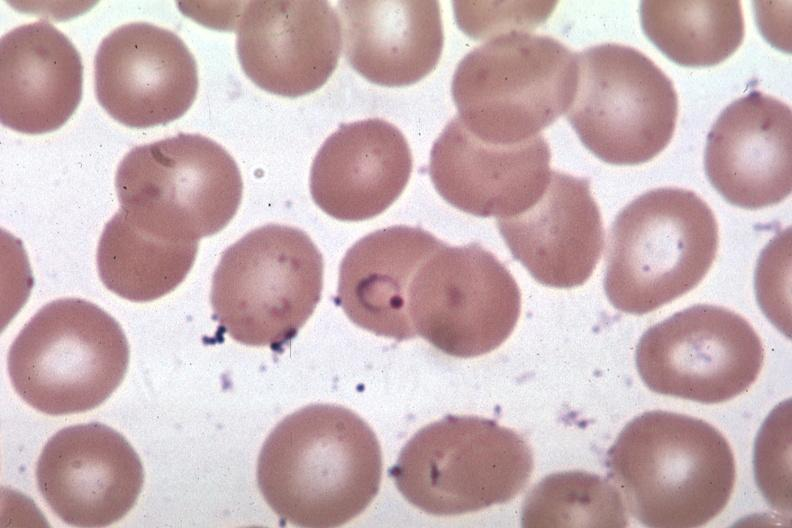s blood present?
Answer the question using a single word or phrase. Yes 